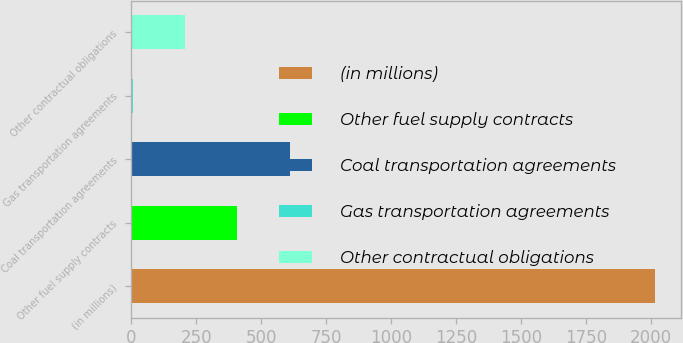Convert chart to OTSL. <chart><loc_0><loc_0><loc_500><loc_500><bar_chart><fcel>(in millions)<fcel>Other fuel supply contracts<fcel>Coal transportation agreements<fcel>Gas transportation agreements<fcel>Other contractual obligations<nl><fcel>2015<fcel>408.6<fcel>609.4<fcel>7<fcel>207.8<nl></chart> 